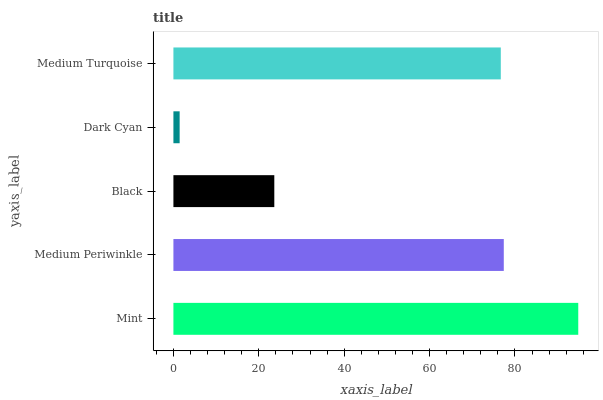Is Dark Cyan the minimum?
Answer yes or no. Yes. Is Mint the maximum?
Answer yes or no. Yes. Is Medium Periwinkle the minimum?
Answer yes or no. No. Is Medium Periwinkle the maximum?
Answer yes or no. No. Is Mint greater than Medium Periwinkle?
Answer yes or no. Yes. Is Medium Periwinkle less than Mint?
Answer yes or no. Yes. Is Medium Periwinkle greater than Mint?
Answer yes or no. No. Is Mint less than Medium Periwinkle?
Answer yes or no. No. Is Medium Turquoise the high median?
Answer yes or no. Yes. Is Medium Turquoise the low median?
Answer yes or no. Yes. Is Dark Cyan the high median?
Answer yes or no. No. Is Dark Cyan the low median?
Answer yes or no. No. 